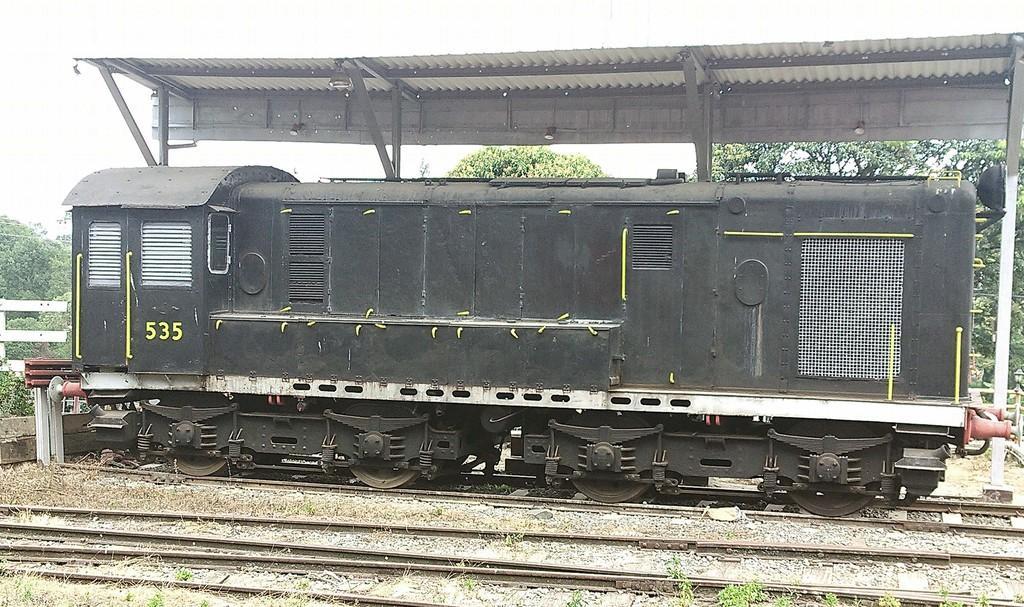Please provide a concise description of this image. In the foreground I can see a train engine on the track. In the background I can see a platform, trees and the sky. This image is taken may be during a day. 